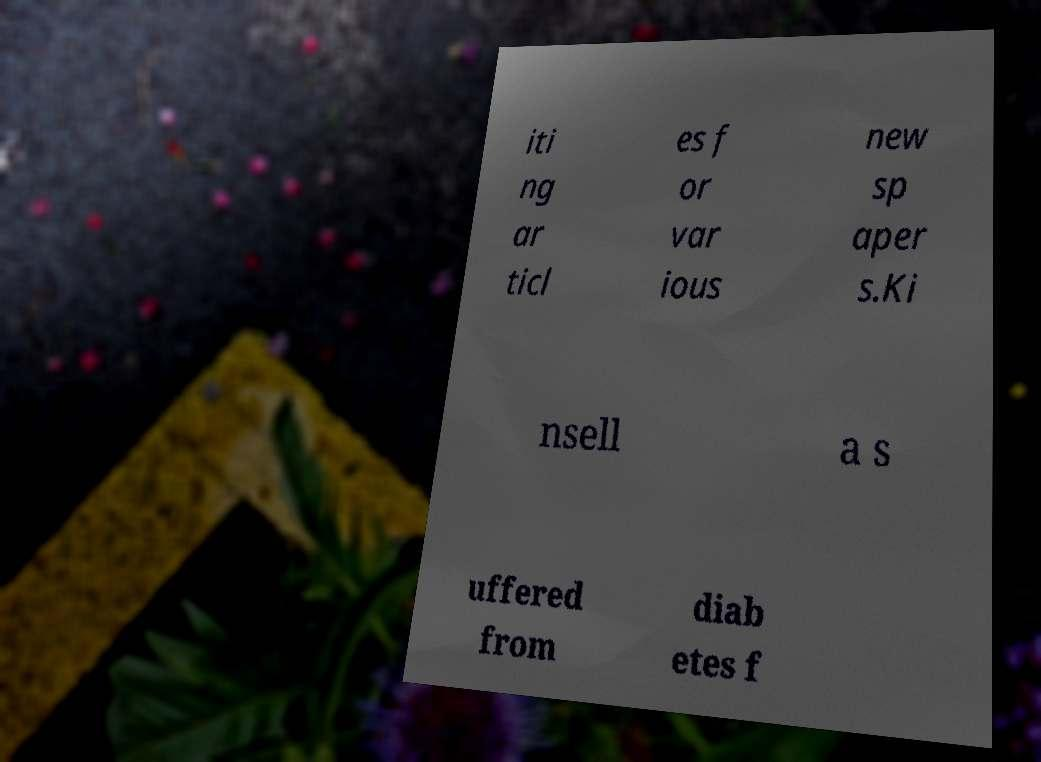For documentation purposes, I need the text within this image transcribed. Could you provide that? iti ng ar ticl es f or var ious new sp aper s.Ki nsell a s uffered from diab etes f 